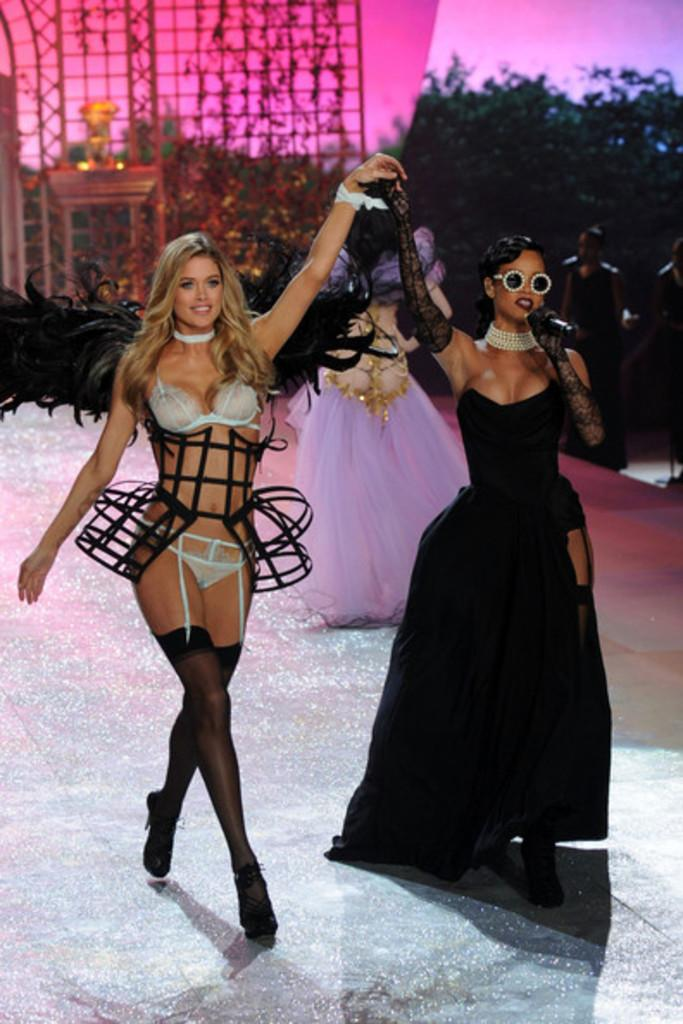Who or what can be seen in the image? There are people in the image. What can be seen in the distance in the image? There are trees in the background of the image. What is the woman in the image holding? The woman is holding a mic in the image. What type of stitch is being used to sew the ice in the image? There is no ice or stitching present in the image. 